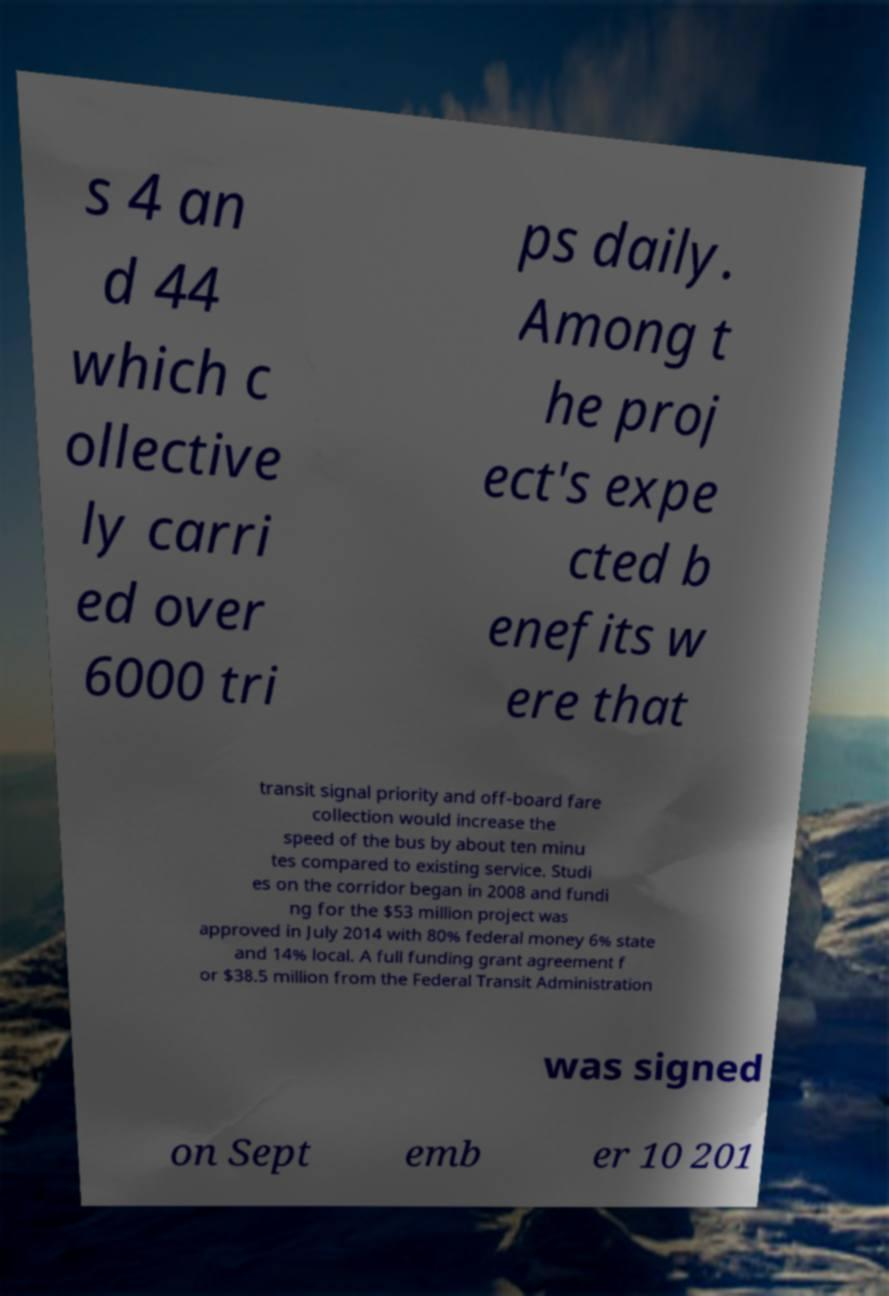There's text embedded in this image that I need extracted. Can you transcribe it verbatim? s 4 an d 44 which c ollective ly carri ed over 6000 tri ps daily. Among t he proj ect's expe cted b enefits w ere that transit signal priority and off-board fare collection would increase the speed of the bus by about ten minu tes compared to existing service. Studi es on the corridor began in 2008 and fundi ng for the $53 million project was approved in July 2014 with 80% federal money 6% state and 14% local. A full funding grant agreement f or $38.5 million from the Federal Transit Administration was signed on Sept emb er 10 201 